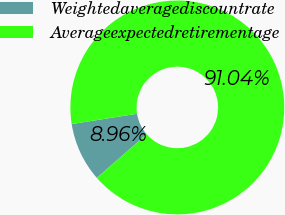Convert chart to OTSL. <chart><loc_0><loc_0><loc_500><loc_500><pie_chart><fcel>Weightedaveragediscountrate<fcel>Averageexpectedretirementage<nl><fcel>8.96%<fcel>91.04%<nl></chart> 